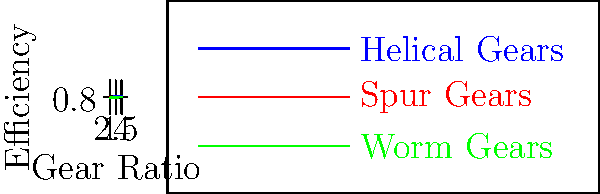As a startup founder focused on optimizing power transmission systems for enhanced net neutrality in data centers, you're evaluating different gear configurations. Based on the efficiency curves shown in the graph, which gear type would you recommend for high gear ratios (4:1) in server cooling systems to maximize energy efficiency and minimize data processing latency? To answer this question, let's analyze the graph step-by-step:

1. The graph shows efficiency curves for three types of gears: Helical, Spur, and Worm gears.
2. The x-axis represents the gear ratio, ranging from 1 to 4.
3. The y-axis represents the efficiency of each gear type.
4. We're interested in the efficiency at a gear ratio of 4:1.

At a gear ratio of 4:1:
- Helical gears: Efficiency ≈ 0.98 (98%)
- Spur gears: Efficiency ≈ 0.90 (90%)
- Worm gears: Efficiency ≈ 0.80 (80%)

Helical gears show the highest efficiency at all gear ratios, including 4:1. Higher efficiency in power transmission systems leads to:

1. Less energy loss during operation
2. Reduced heat generation
3. Lower cooling requirements
4. Improved overall system performance

For a data center application, where energy efficiency and reduced latency are crucial for maintaining net neutrality, the most efficient gear type would be the optimal choice. This would minimize energy consumption, reduce operational costs, and ensure faster data processing by minimizing mechanical losses in the cooling systems.
Answer: Helical gears 